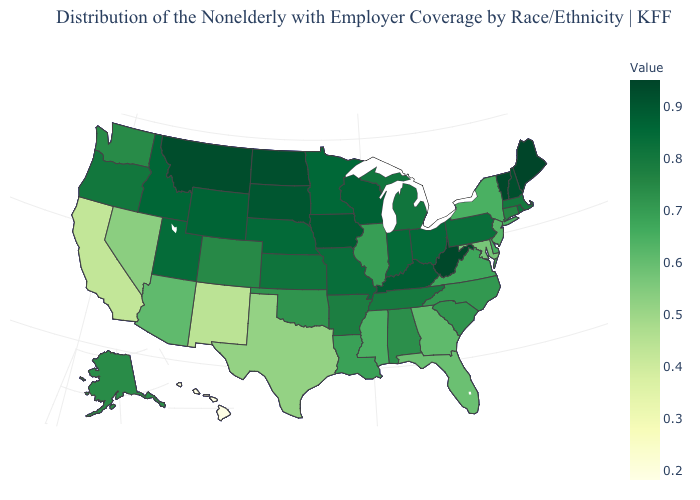Is the legend a continuous bar?
Concise answer only. Yes. Among the states that border South Carolina , does North Carolina have the highest value?
Write a very short answer. Yes. Does Hawaii have the lowest value in the USA?
Keep it brief. Yes. Among the states that border Wisconsin , which have the highest value?
Answer briefly. Iowa. 